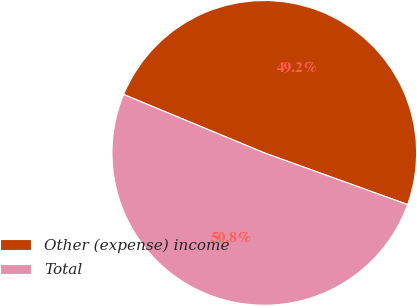<chart> <loc_0><loc_0><loc_500><loc_500><pie_chart><fcel>Other (expense) income<fcel>Total<nl><fcel>49.25%<fcel>50.75%<nl></chart> 